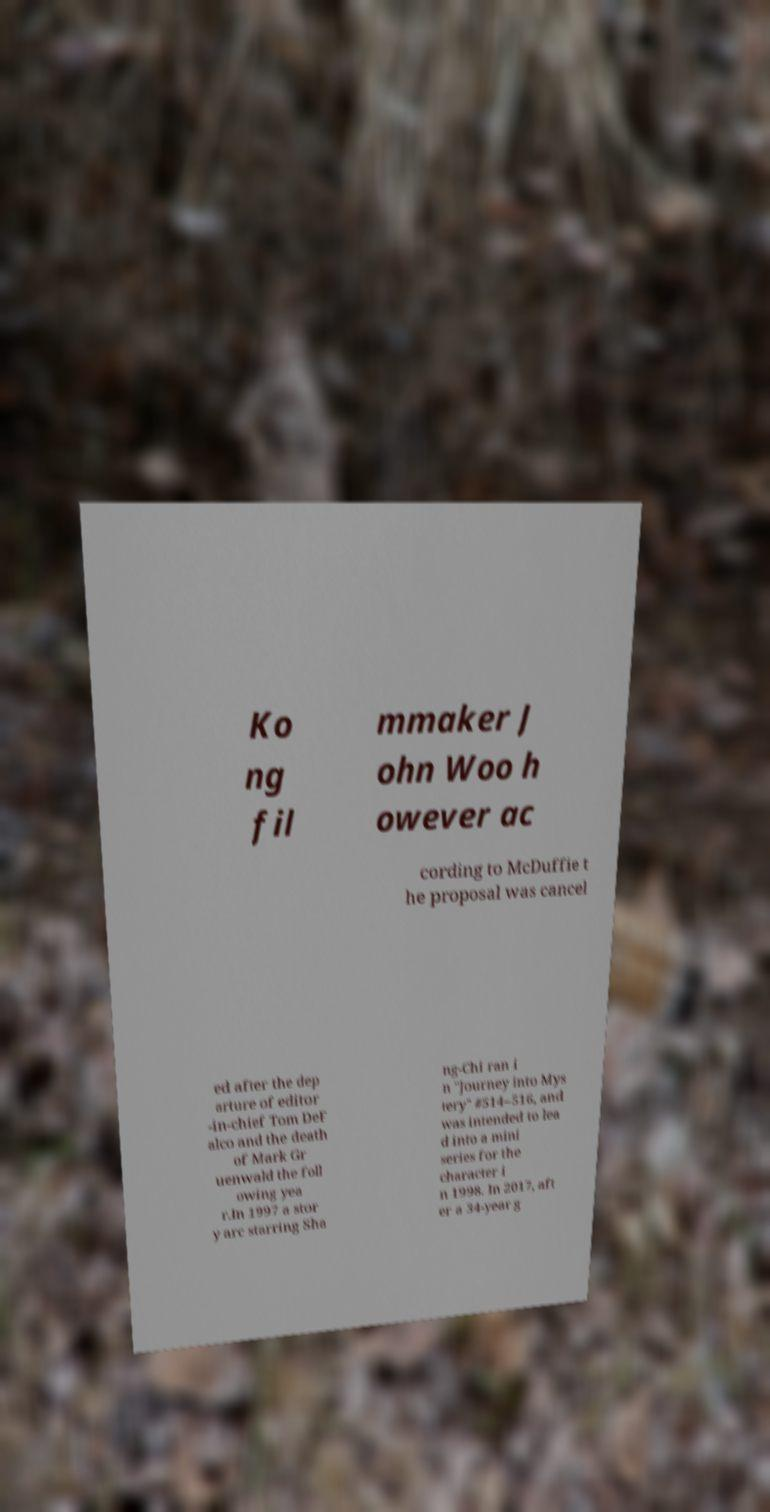For documentation purposes, I need the text within this image transcribed. Could you provide that? Ko ng fil mmaker J ohn Woo h owever ac cording to McDuffie t he proposal was cancel ed after the dep arture of editor -in-chief Tom DeF alco and the death of Mark Gr uenwald the foll owing yea r.In 1997 a stor y arc starring Sha ng-Chi ran i n "Journey into Mys tery" #514–516, and was intended to lea d into a mini series for the character i n 1998. In 2017, aft er a 34-year g 